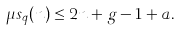Convert formula to latex. <formula><loc_0><loc_0><loc_500><loc_500>\mu s _ { q } ( n ) \leq 2 n + g - 1 + a .</formula> 